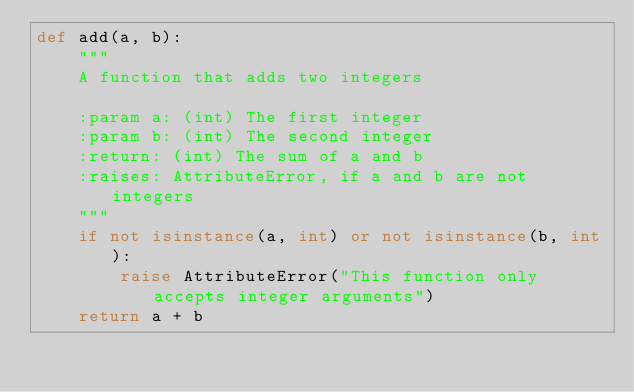<code> <loc_0><loc_0><loc_500><loc_500><_Python_>def add(a, b):
    """
    A function that adds two integers

    :param a: (int) The first integer
    :param b: (int) The second integer
    :return: (int) The sum of a and b
    :raises: AttributeError, if a and b are not integers
    """
    if not isinstance(a, int) or not isinstance(b, int):
        raise AttributeError("This function only accepts integer arguments")
    return a + b
</code> 